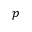Convert formula to latex. <formula><loc_0><loc_0><loc_500><loc_500>p</formula> 